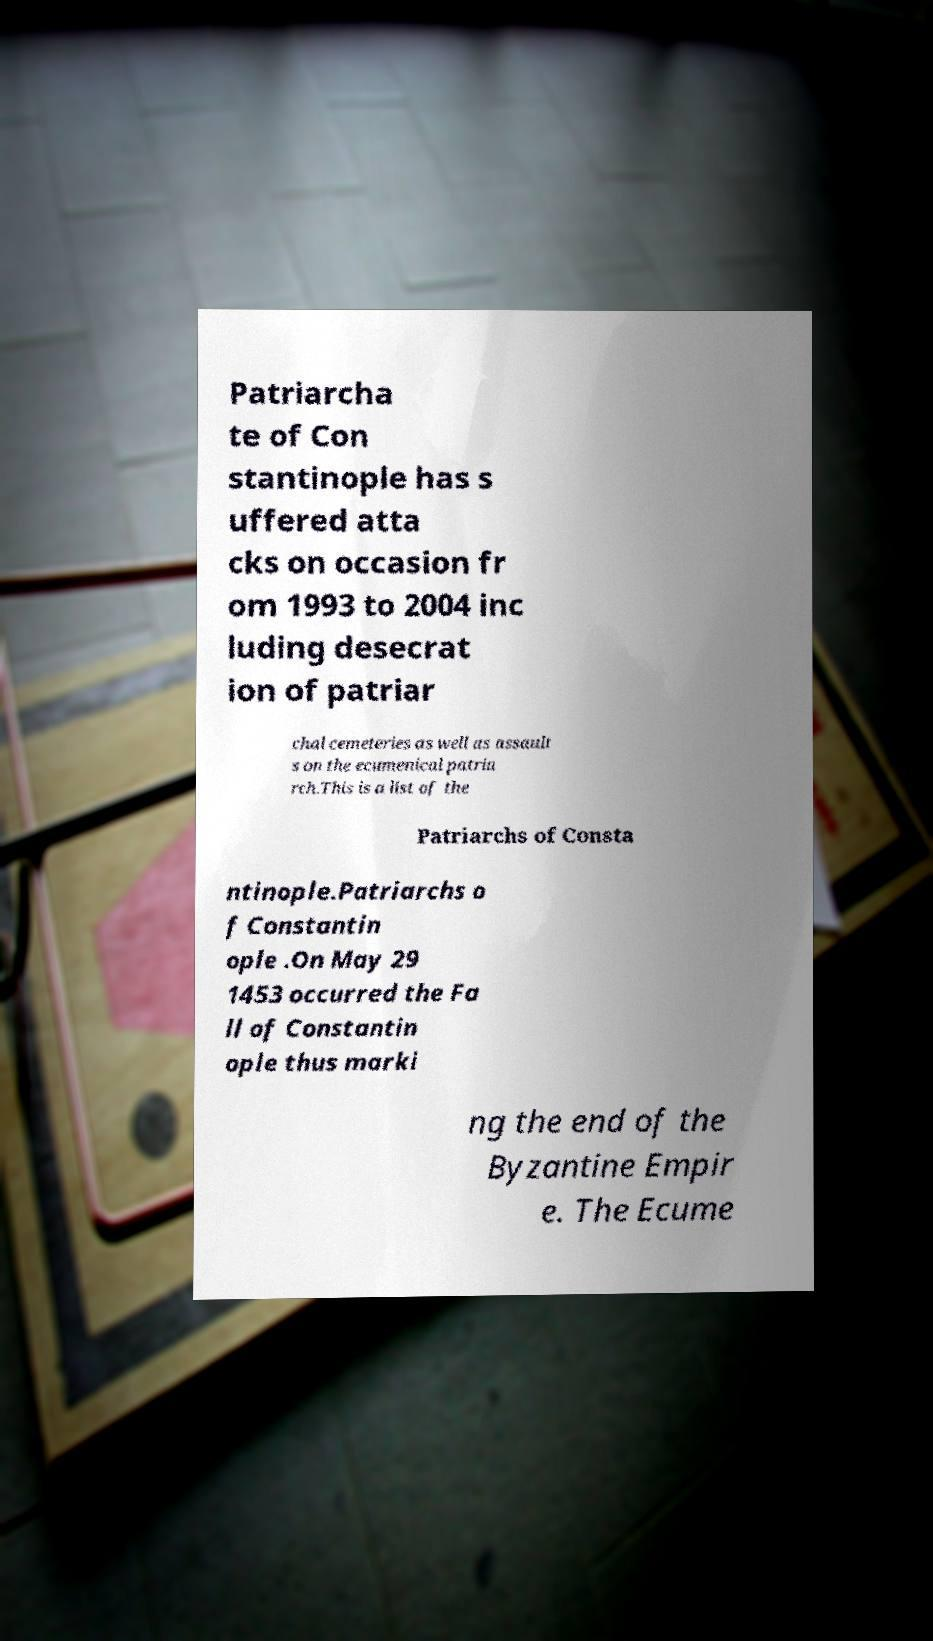What messages or text are displayed in this image? I need them in a readable, typed format. Patriarcha te of Con stantinople has s uffered atta cks on occasion fr om 1993 to 2004 inc luding desecrat ion of patriar chal cemeteries as well as assault s on the ecumenical patria rch.This is a list of the Patriarchs of Consta ntinople.Patriarchs o f Constantin ople .On May 29 1453 occurred the Fa ll of Constantin ople thus marki ng the end of the Byzantine Empir e. The Ecume 